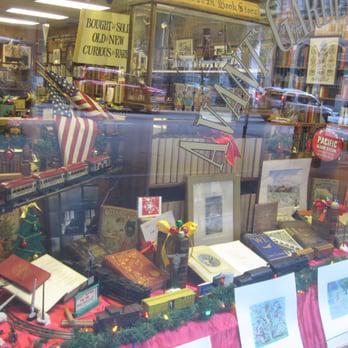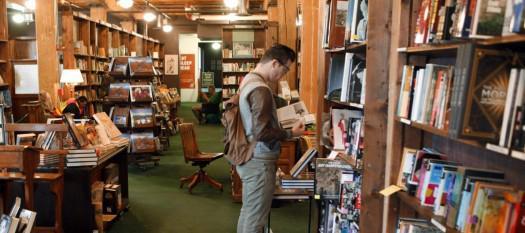The first image is the image on the left, the second image is the image on the right. Evaluate the accuracy of this statement regarding the images: "A man is near some books.". Is it true? Answer yes or no. Yes. 